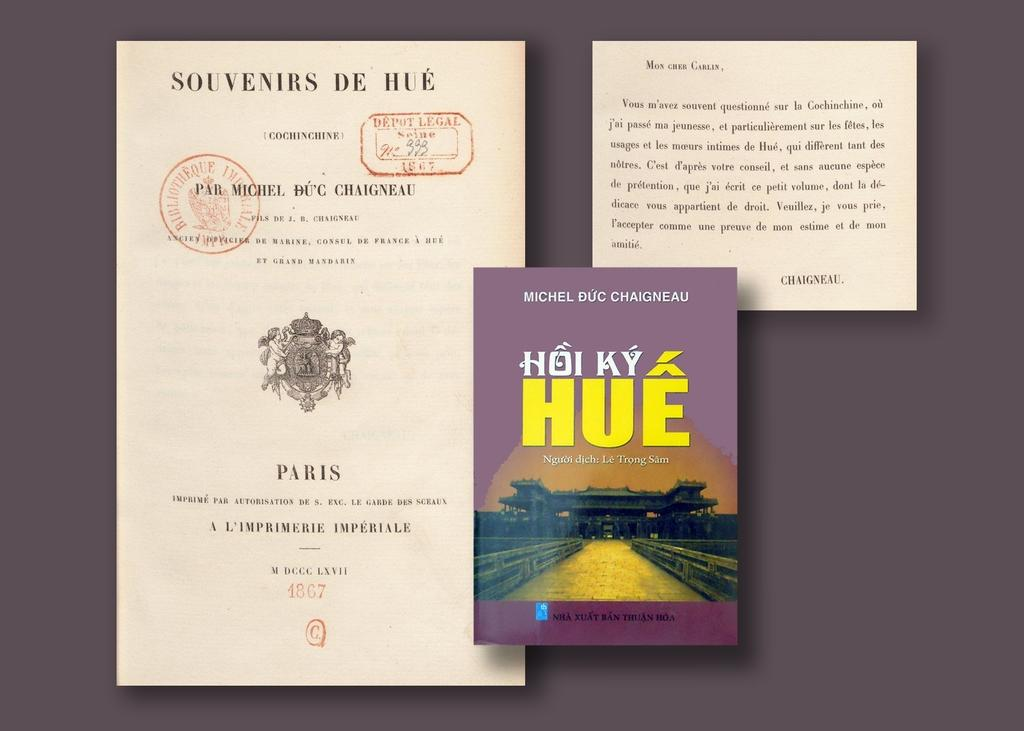Provide a one-sentence caption for the provided image. Book resting on a table that is titled "Hoi Ky Hue". 